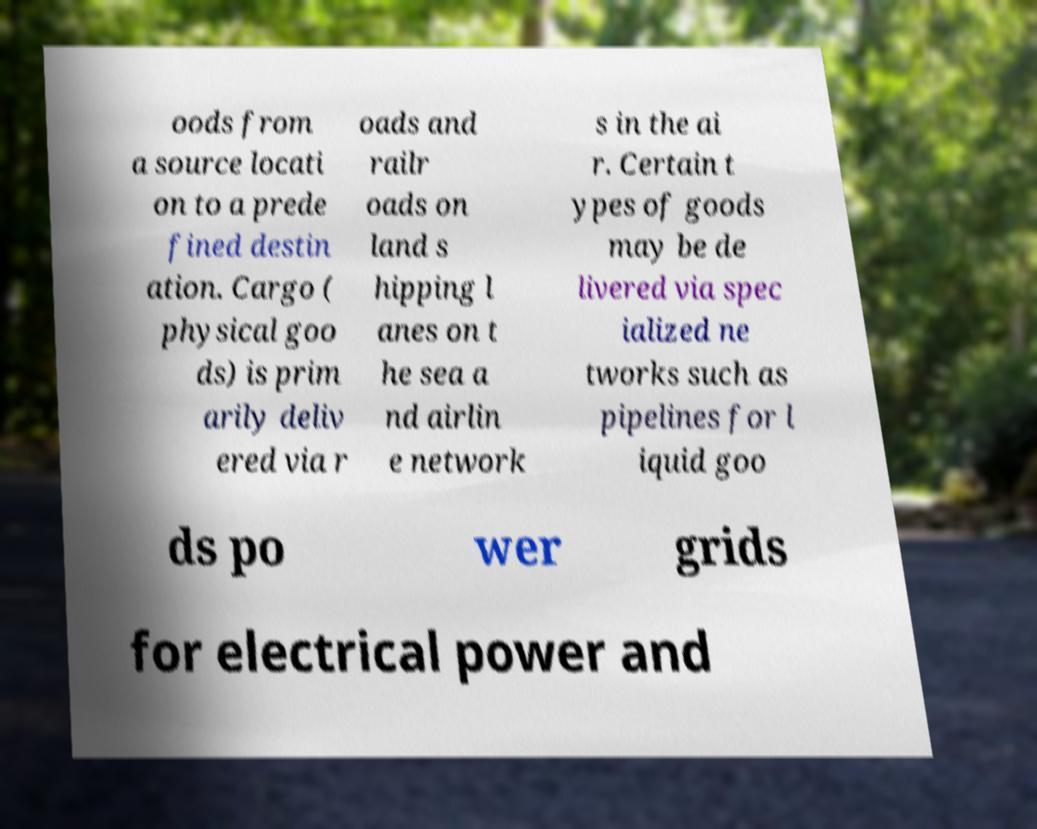Please identify and transcribe the text found in this image. oods from a source locati on to a prede fined destin ation. Cargo ( physical goo ds) is prim arily deliv ered via r oads and railr oads on land s hipping l anes on t he sea a nd airlin e network s in the ai r. Certain t ypes of goods may be de livered via spec ialized ne tworks such as pipelines for l iquid goo ds po wer grids for electrical power and 